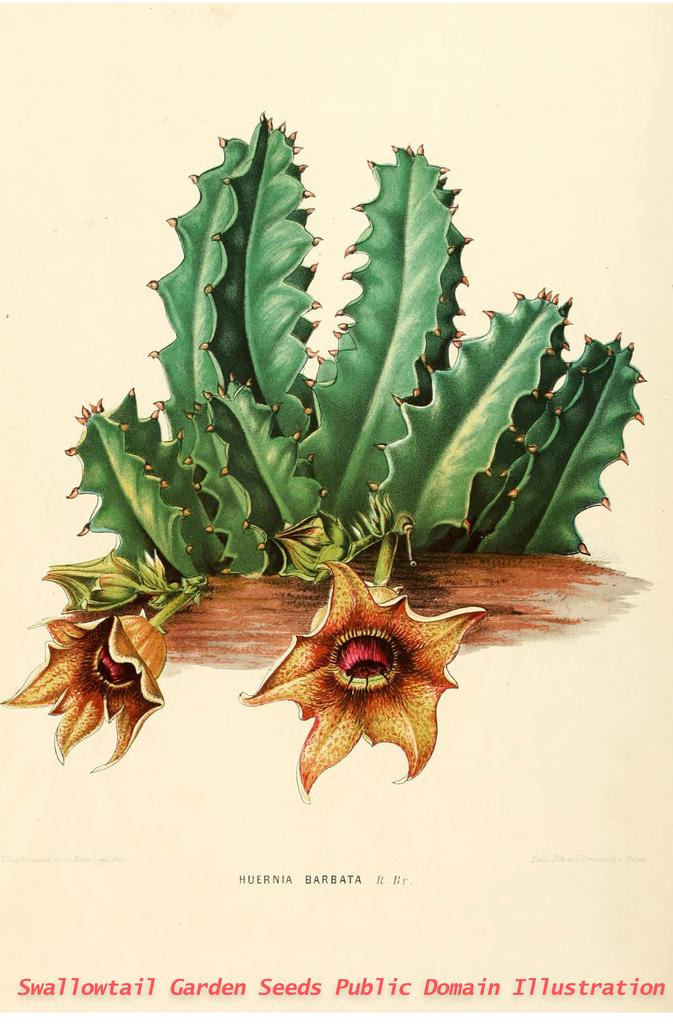What colors are the flowers in the image? The flowers in the image are in brown and red colors. What color are the plants in the image? The plants in the image are in green color. What color is the background of the image? The background of the image is cream-colored. What can be seen in addition to the flowers and plants in the image? There is text or writing visible in the image. Can you tell me how many friends are standing next to the woman in the image? There is no woman or friends present in the image; it features flowers and plants with a cream-colored background and text or writing. 